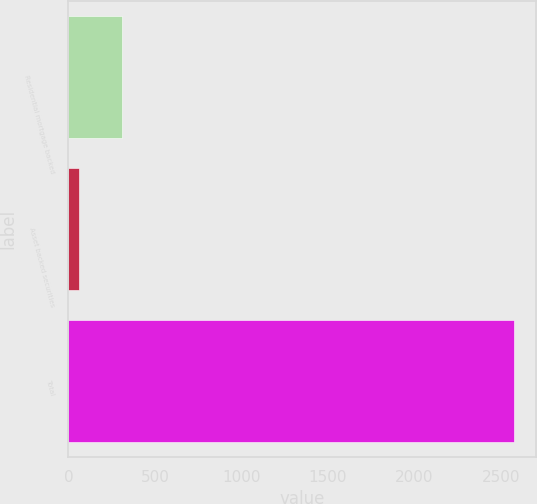Convert chart to OTSL. <chart><loc_0><loc_0><loc_500><loc_500><bar_chart><fcel>Residential mortgage backed<fcel>Asset backed securities<fcel>Total<nl><fcel>312.4<fcel>61<fcel>2575<nl></chart> 